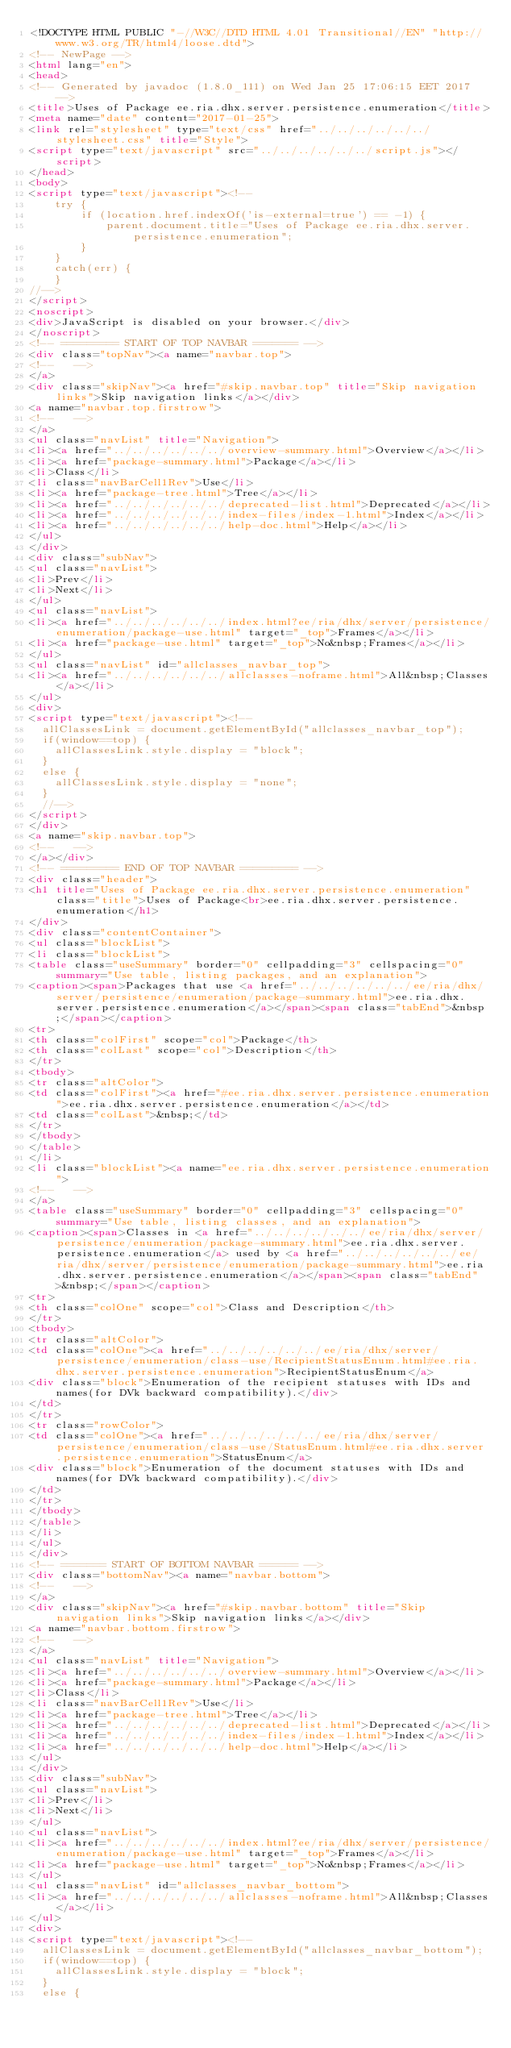<code> <loc_0><loc_0><loc_500><loc_500><_HTML_><!DOCTYPE HTML PUBLIC "-//W3C//DTD HTML 4.01 Transitional//EN" "http://www.w3.org/TR/html4/loose.dtd">
<!-- NewPage -->
<html lang="en">
<head>
<!-- Generated by javadoc (1.8.0_111) on Wed Jan 25 17:06:15 EET 2017 -->
<title>Uses of Package ee.ria.dhx.server.persistence.enumeration</title>
<meta name="date" content="2017-01-25">
<link rel="stylesheet" type="text/css" href="../../../../../../stylesheet.css" title="Style">
<script type="text/javascript" src="../../../../../../script.js"></script>
</head>
<body>
<script type="text/javascript"><!--
    try {
        if (location.href.indexOf('is-external=true') == -1) {
            parent.document.title="Uses of Package ee.ria.dhx.server.persistence.enumeration";
        }
    }
    catch(err) {
    }
//-->
</script>
<noscript>
<div>JavaScript is disabled on your browser.</div>
</noscript>
<!-- ========= START OF TOP NAVBAR ======= -->
<div class="topNav"><a name="navbar.top">
<!--   -->
</a>
<div class="skipNav"><a href="#skip.navbar.top" title="Skip navigation links">Skip navigation links</a></div>
<a name="navbar.top.firstrow">
<!--   -->
</a>
<ul class="navList" title="Navigation">
<li><a href="../../../../../../overview-summary.html">Overview</a></li>
<li><a href="package-summary.html">Package</a></li>
<li>Class</li>
<li class="navBarCell1Rev">Use</li>
<li><a href="package-tree.html">Tree</a></li>
<li><a href="../../../../../../deprecated-list.html">Deprecated</a></li>
<li><a href="../../../../../../index-files/index-1.html">Index</a></li>
<li><a href="../../../../../../help-doc.html">Help</a></li>
</ul>
</div>
<div class="subNav">
<ul class="navList">
<li>Prev</li>
<li>Next</li>
</ul>
<ul class="navList">
<li><a href="../../../../../../index.html?ee/ria/dhx/server/persistence/enumeration/package-use.html" target="_top">Frames</a></li>
<li><a href="package-use.html" target="_top">No&nbsp;Frames</a></li>
</ul>
<ul class="navList" id="allclasses_navbar_top">
<li><a href="../../../../../../allclasses-noframe.html">All&nbsp;Classes</a></li>
</ul>
<div>
<script type="text/javascript"><!--
  allClassesLink = document.getElementById("allclasses_navbar_top");
  if(window==top) {
    allClassesLink.style.display = "block";
  }
  else {
    allClassesLink.style.display = "none";
  }
  //-->
</script>
</div>
<a name="skip.navbar.top">
<!--   -->
</a></div>
<!-- ========= END OF TOP NAVBAR ========= -->
<div class="header">
<h1 title="Uses of Package ee.ria.dhx.server.persistence.enumeration" class="title">Uses of Package<br>ee.ria.dhx.server.persistence.enumeration</h1>
</div>
<div class="contentContainer">
<ul class="blockList">
<li class="blockList">
<table class="useSummary" border="0" cellpadding="3" cellspacing="0" summary="Use table, listing packages, and an explanation">
<caption><span>Packages that use <a href="../../../../../../ee/ria/dhx/server/persistence/enumeration/package-summary.html">ee.ria.dhx.server.persistence.enumeration</a></span><span class="tabEnd">&nbsp;</span></caption>
<tr>
<th class="colFirst" scope="col">Package</th>
<th class="colLast" scope="col">Description</th>
</tr>
<tbody>
<tr class="altColor">
<td class="colFirst"><a href="#ee.ria.dhx.server.persistence.enumeration">ee.ria.dhx.server.persistence.enumeration</a></td>
<td class="colLast">&nbsp;</td>
</tr>
</tbody>
</table>
</li>
<li class="blockList"><a name="ee.ria.dhx.server.persistence.enumeration">
<!--   -->
</a>
<table class="useSummary" border="0" cellpadding="3" cellspacing="0" summary="Use table, listing classes, and an explanation">
<caption><span>Classes in <a href="../../../../../../ee/ria/dhx/server/persistence/enumeration/package-summary.html">ee.ria.dhx.server.persistence.enumeration</a> used by <a href="../../../../../../ee/ria/dhx/server/persistence/enumeration/package-summary.html">ee.ria.dhx.server.persistence.enumeration</a></span><span class="tabEnd">&nbsp;</span></caption>
<tr>
<th class="colOne" scope="col">Class and Description</th>
</tr>
<tbody>
<tr class="altColor">
<td class="colOne"><a href="../../../../../../ee/ria/dhx/server/persistence/enumeration/class-use/RecipientStatusEnum.html#ee.ria.dhx.server.persistence.enumeration">RecipientStatusEnum</a>
<div class="block">Enumeration of the recipient statuses with IDs and names(for DVk backward compatibility).</div>
</td>
</tr>
<tr class="rowColor">
<td class="colOne"><a href="../../../../../../ee/ria/dhx/server/persistence/enumeration/class-use/StatusEnum.html#ee.ria.dhx.server.persistence.enumeration">StatusEnum</a>
<div class="block">Enumeration of the document statuses with IDs and names(for DVk backward compatibility).</div>
</td>
</tr>
</tbody>
</table>
</li>
</ul>
</div>
<!-- ======= START OF BOTTOM NAVBAR ====== -->
<div class="bottomNav"><a name="navbar.bottom">
<!--   -->
</a>
<div class="skipNav"><a href="#skip.navbar.bottom" title="Skip navigation links">Skip navigation links</a></div>
<a name="navbar.bottom.firstrow">
<!--   -->
</a>
<ul class="navList" title="Navigation">
<li><a href="../../../../../../overview-summary.html">Overview</a></li>
<li><a href="package-summary.html">Package</a></li>
<li>Class</li>
<li class="navBarCell1Rev">Use</li>
<li><a href="package-tree.html">Tree</a></li>
<li><a href="../../../../../../deprecated-list.html">Deprecated</a></li>
<li><a href="../../../../../../index-files/index-1.html">Index</a></li>
<li><a href="../../../../../../help-doc.html">Help</a></li>
</ul>
</div>
<div class="subNav">
<ul class="navList">
<li>Prev</li>
<li>Next</li>
</ul>
<ul class="navList">
<li><a href="../../../../../../index.html?ee/ria/dhx/server/persistence/enumeration/package-use.html" target="_top">Frames</a></li>
<li><a href="package-use.html" target="_top">No&nbsp;Frames</a></li>
</ul>
<ul class="navList" id="allclasses_navbar_bottom">
<li><a href="../../../../../../allclasses-noframe.html">All&nbsp;Classes</a></li>
</ul>
<div>
<script type="text/javascript"><!--
  allClassesLink = document.getElementById("allclasses_navbar_bottom");
  if(window==top) {
    allClassesLink.style.display = "block";
  }
  else {</code> 